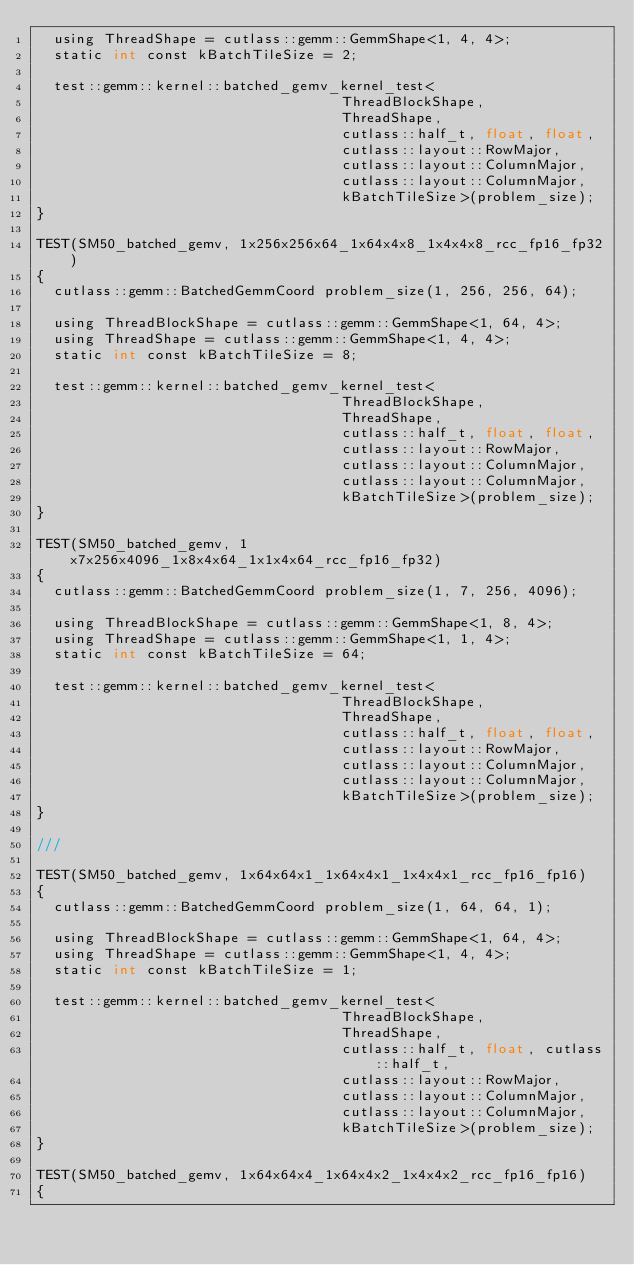<code> <loc_0><loc_0><loc_500><loc_500><_Cuda_>  using ThreadShape = cutlass::gemm::GemmShape<1, 4, 4>;
  static int const kBatchTileSize = 2;

  test::gemm::kernel::batched_gemv_kernel_test<
                                    ThreadBlockShape,
                                    ThreadShape,
                                    cutlass::half_t, float, float,
                                    cutlass::layout::RowMajor,
                                    cutlass::layout::ColumnMajor,
                                    cutlass::layout::ColumnMajor,
                                    kBatchTileSize>(problem_size);
}

TEST(SM50_batched_gemv, 1x256x256x64_1x64x4x8_1x4x4x8_rcc_fp16_fp32)
{
  cutlass::gemm::BatchedGemmCoord problem_size(1, 256, 256, 64);

  using ThreadBlockShape = cutlass::gemm::GemmShape<1, 64, 4>;
  using ThreadShape = cutlass::gemm::GemmShape<1, 4, 4>;
  static int const kBatchTileSize = 8;

  test::gemm::kernel::batched_gemv_kernel_test<
                                    ThreadBlockShape,
                                    ThreadShape,
                                    cutlass::half_t, float, float,
                                    cutlass::layout::RowMajor,
                                    cutlass::layout::ColumnMajor,
                                    cutlass::layout::ColumnMajor,
                                    kBatchTileSize>(problem_size);
}

TEST(SM50_batched_gemv, 1x7x256x4096_1x8x4x64_1x1x4x64_rcc_fp16_fp32)
{
  cutlass::gemm::BatchedGemmCoord problem_size(1, 7, 256, 4096);

  using ThreadBlockShape = cutlass::gemm::GemmShape<1, 8, 4>;
  using ThreadShape = cutlass::gemm::GemmShape<1, 1, 4>;
  static int const kBatchTileSize = 64;

  test::gemm::kernel::batched_gemv_kernel_test<
                                    ThreadBlockShape,
                                    ThreadShape,
                                    cutlass::half_t, float, float,
                                    cutlass::layout::RowMajor,
                                    cutlass::layout::ColumnMajor,
                                    cutlass::layout::ColumnMajor,
                                    kBatchTileSize>(problem_size);
}

///

TEST(SM50_batched_gemv, 1x64x64x1_1x64x4x1_1x4x4x1_rcc_fp16_fp16)
{
  cutlass::gemm::BatchedGemmCoord problem_size(1, 64, 64, 1);

  using ThreadBlockShape = cutlass::gemm::GemmShape<1, 64, 4>;
  using ThreadShape = cutlass::gemm::GemmShape<1, 4, 4>;
  static int const kBatchTileSize = 1;

  test::gemm::kernel::batched_gemv_kernel_test<
                                    ThreadBlockShape,
                                    ThreadShape,
                                    cutlass::half_t, float, cutlass::half_t,
                                    cutlass::layout::RowMajor,
                                    cutlass::layout::ColumnMajor,
                                    cutlass::layout::ColumnMajor,
                                    kBatchTileSize>(problem_size);
}

TEST(SM50_batched_gemv, 1x64x64x4_1x64x4x2_1x4x4x2_rcc_fp16_fp16)
{</code> 